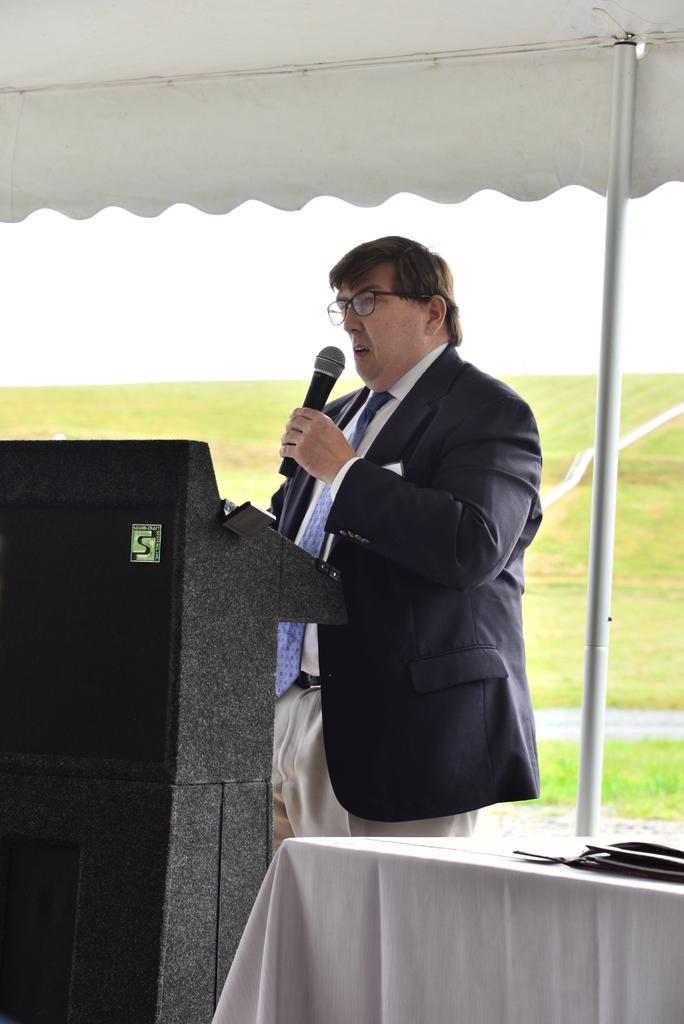What is the man in the image doing? The man is standing in the image. What can be observed about the man's attire? The man is wearing clothes and spectacles. What object is the man holding in his hand? The man is holding a microphone in his hand. What structure is present in the image? There is a podium in the image. What type of shelter is visible in the image? There is a tent in the image. What piece of furniture is present in the image? There is a table in the image. What type of natural environment is visible in the image? Grass is visible in the image. What part of the sky is visible in the image? The sky is visible in the image. What type of wristwatch is the man wearing in the image? The man is not wearing a wristwatch in the image. How many pockets can be seen on the man's clothing in the image? There is no information about pockets on the man's clothing in the image. What is the tent doing in the image? The tent is not performing any action in the image; it is a stationary structure. 